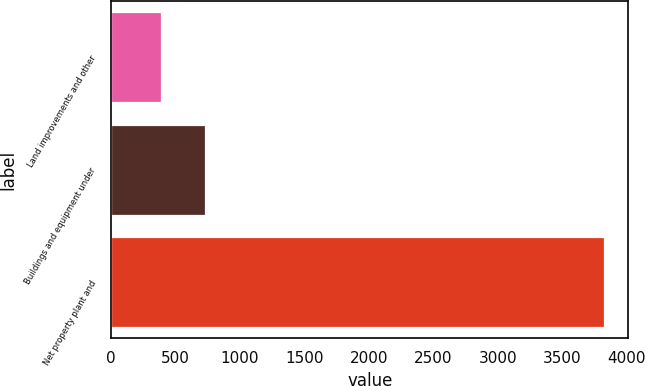<chart> <loc_0><loc_0><loc_500><loc_500><bar_chart><fcel>Land improvements and other<fcel>Buildings and equipment under<fcel>Net property plant and<nl><fcel>386<fcel>729.7<fcel>3823<nl></chart> 